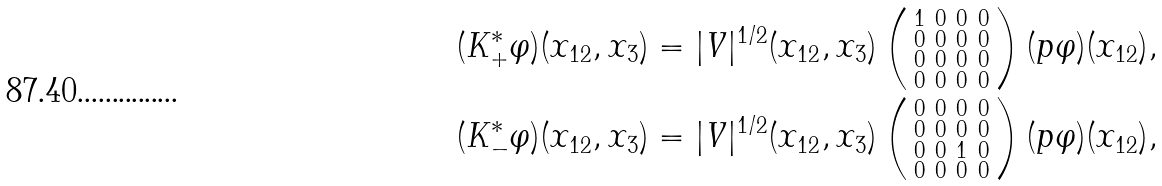Convert formula to latex. <formula><loc_0><loc_0><loc_500><loc_500>( K ^ { \ast } _ { + } \varphi ) ( x _ { 1 2 } , x _ { 3 } ) & = | V | ^ { 1 / 2 } ( x _ { 1 2 } , x _ { 3 } ) \left ( \begin{smallmatrix} 1 & 0 & 0 & 0 \\ 0 & 0 & 0 & 0 \\ 0 & 0 & 0 & 0 \\ 0 & 0 & 0 & 0 \end{smallmatrix} \right ) ( p \varphi ) ( x _ { 1 2 } ) , \\ ( K ^ { \ast } _ { - } \varphi ) ( x _ { 1 2 } , x _ { 3 } ) & = | V | ^ { 1 / 2 } ( x _ { 1 2 } , x _ { 3 } ) \left ( \begin{smallmatrix} 0 & 0 & 0 & 0 \\ 0 & 0 & 0 & 0 \\ 0 & 0 & 1 & 0 \\ 0 & 0 & 0 & 0 \end{smallmatrix} \right ) ( p \varphi ) ( x _ { 1 2 } ) ,</formula> 